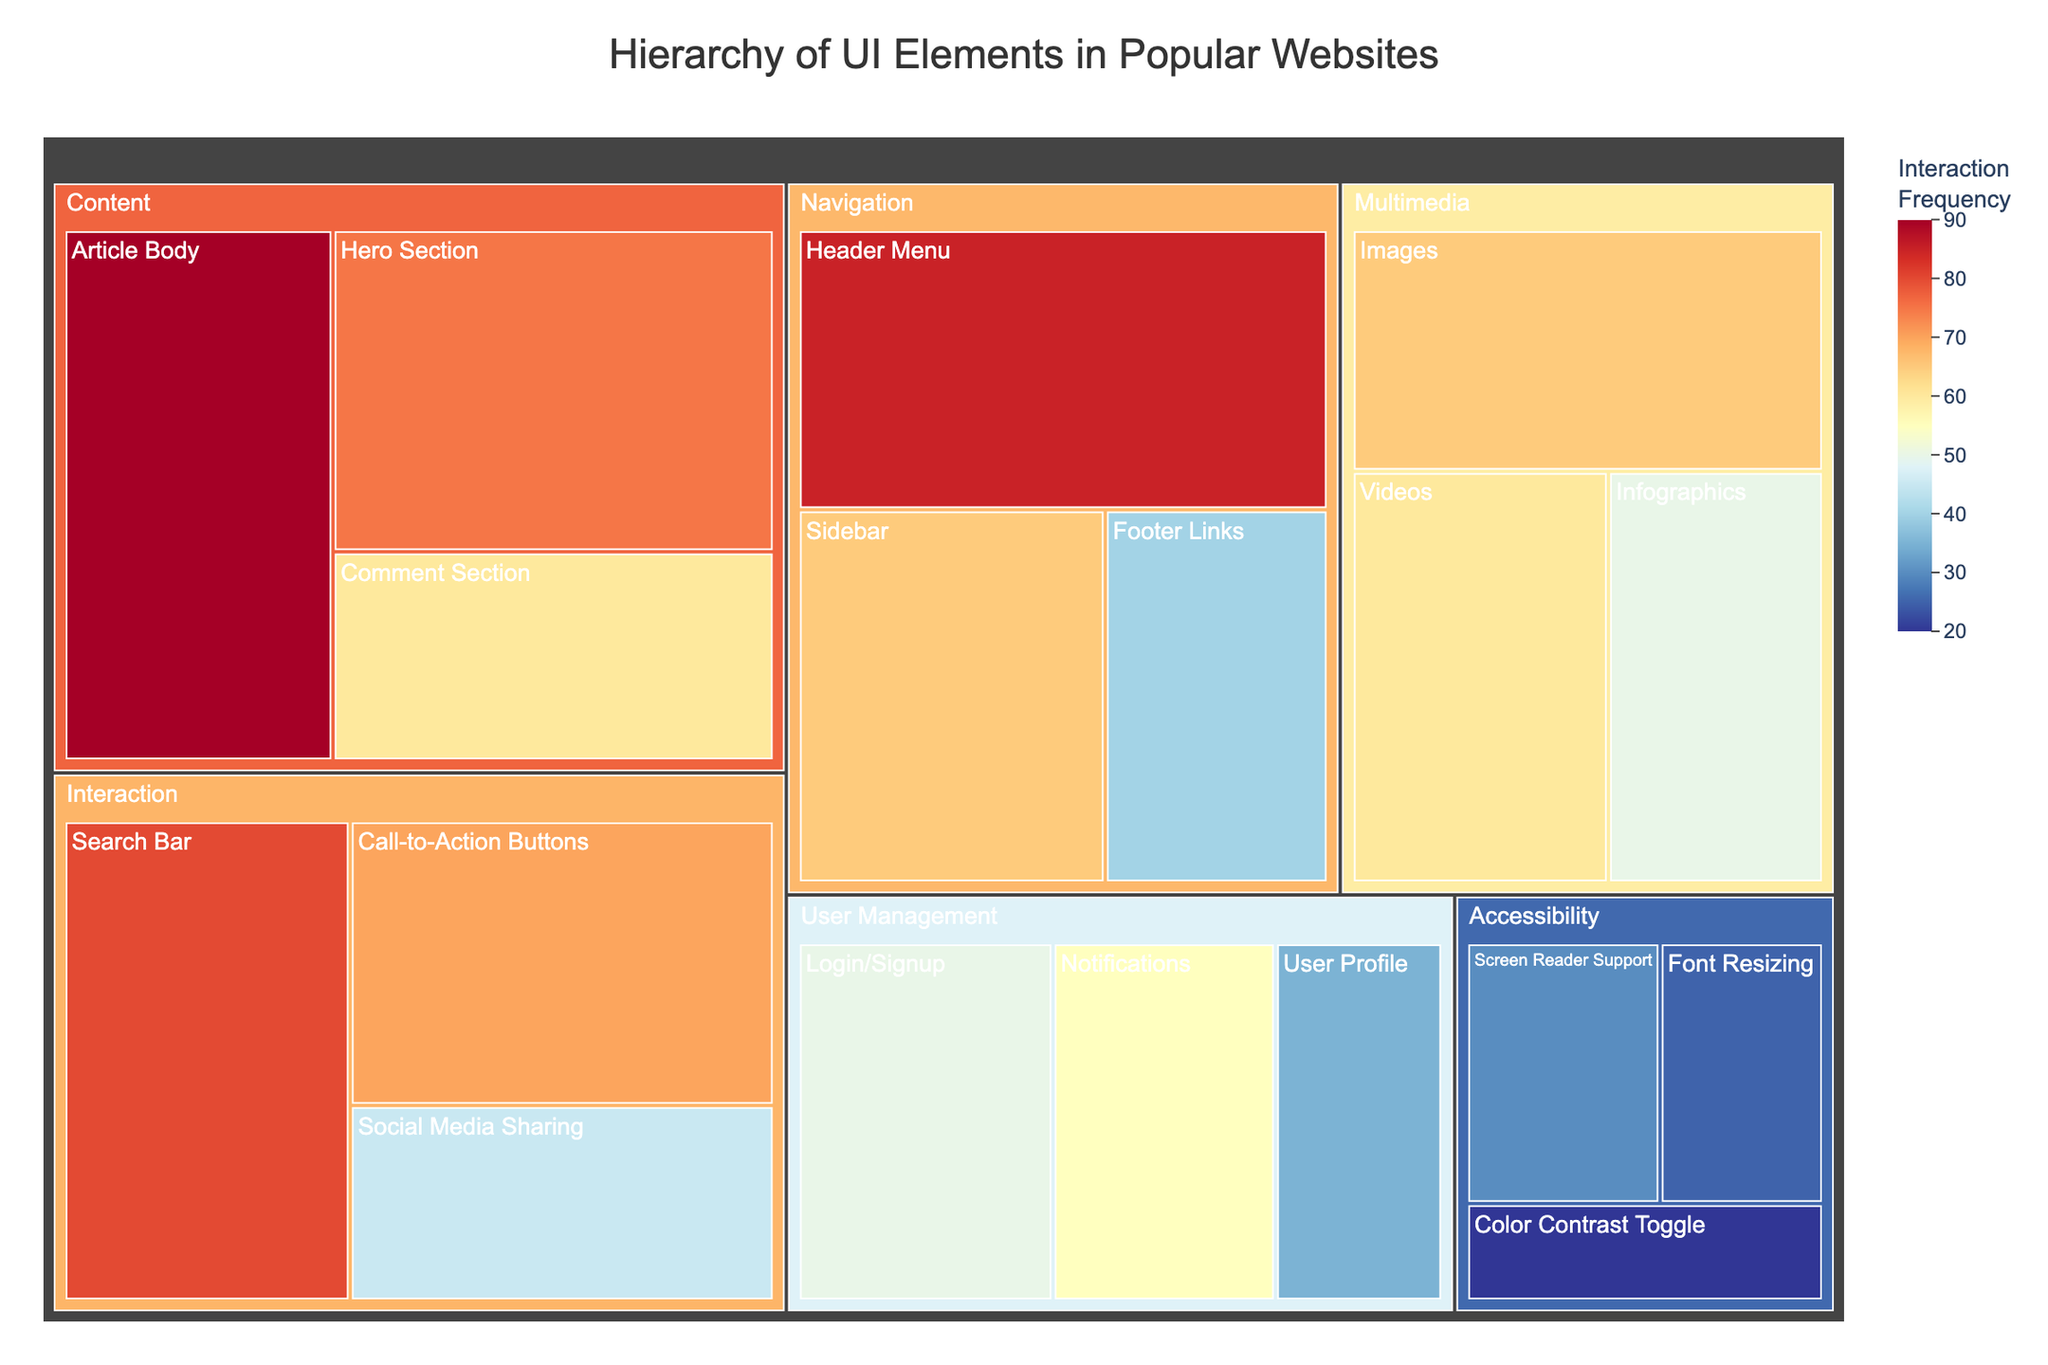What is the title of the figure? The title is usually located at the top of the figure. In this case, the title "Hierarchy of UI Elements in Popular Websites" is centered at the top of the plot.
Answer: Hierarchy of UI Elements in Popular Websites How are the UI elements categorized? The categories are shown as groups that contain different elements. The categories listed in the figure are Navigation, Content, Interaction, User Management, Multimedia, and Accessibility.
Answer: Navigation, Content, Interaction, User Management, Multimedia, Accessibility Which UI element has the highest interaction frequency? The interaction frequency can be identified by the color intensity and hover information. The element "Article Body" within the Content category has an interaction frequency of 90, which is the highest in the provided data.
Answer: Article Body Compare the prominence of the Hero Section and the Header Menu. Which one is more prominent and by how much? By observing the hover information, the Hero Section has a prominence of 95, while the Header Menu has a prominence of 90. The Hero Section is more prominent by 5 units.
Answer: Hero Section by 5 What is the size of the Search Bar's prominence and interaction frequency combined? The size is determined by the square root of the product of prominence and interaction frequency. For the Search Bar, the calculation is √(85 * 80) = √6800 = approximately 82.46.
Answer: 82.46 Which category contains the least prominent element? By examining the prominence values in the hover information, the element "Color Contrast Toggle" in the Accessibility category has the lowest prominence of 25.
Answer: Accessibility What is the color range used for interaction frequency in the figure? The color range is indicated by the color bar next to the treemap. It ranges from 20 to 90 on the interaction frequency scale.
Answer: 20 to 90 List all elements under the User Management category and their interaction frequencies. By looking at the User Management section, the elements and their interaction frequencies are: Login/Signup (50), User Profile (35), Notifications (55).
Answer: Login/Signup (50), User Profile (35), Notifications (55) Which has a higher size value: the Sidebar or the Comment Section, and what are their respective values? The size is calculated by the square root of the product of prominence and interaction frequency. For Sidebar, it's √(70 * 65) ≈ 67.82. For Comment Section, it's √(50 * 60) ≈ 54.77. The Sidebar has a higher size value.
Answer: Sidebar, Sidebar: 67.82, Comment Section: 54.77 What is the prominence of the least interacted multimedia element? By examining the Multimedia category and finding the element with the lowest interaction frequency, which is Infographics at 50. Its prominence is also provided in the hover information as 55.
Answer: 55 